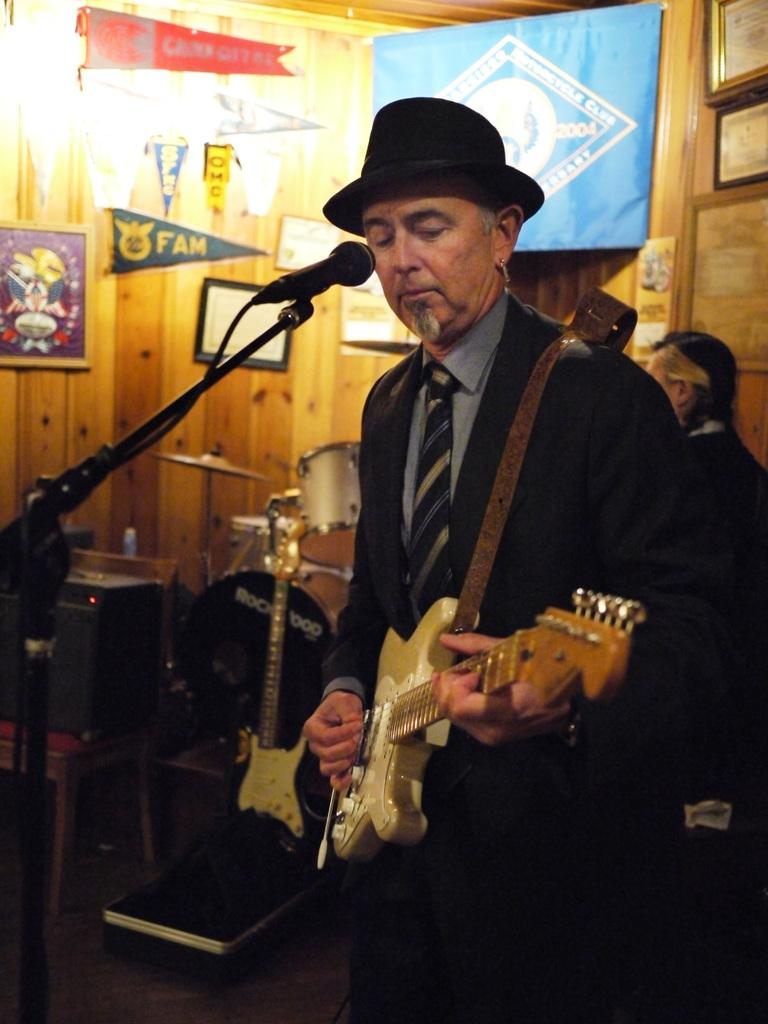What is the man in the image holding? The man is holding a guitar. What object is present in the image that is commonly used for amplifying sound? There is a microphone in the image. What type of religious ceremony is the man participating in with his guitar and microphone in the image? There is no indication of a religious ceremony in the image; the man is simply holding a guitar and there is a microphone present. What type of breakfast food is the man eating while playing the guitar in the image? There is no breakfast food present in the image; the man is only holding a guitar and there is a microphone nearby. 